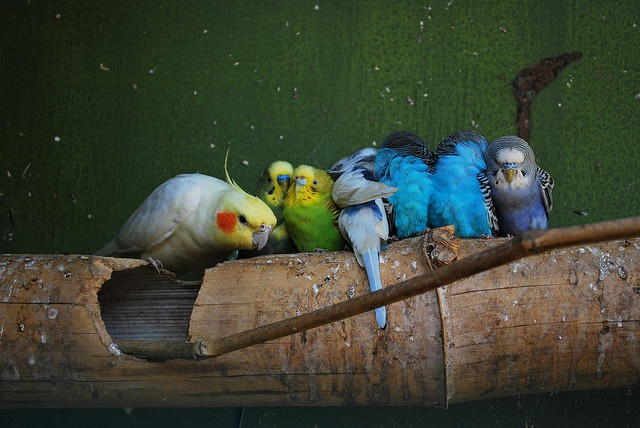Describe the objects in this image and their specific colors. I can see bird in black, gray, darkgray, and darkgreen tones, bird in black, teal, and blue tones, bird in black, gray, and darkgray tones, bird in black, darkgray, lightblue, and gray tones, and bird in black and teal tones in this image. 